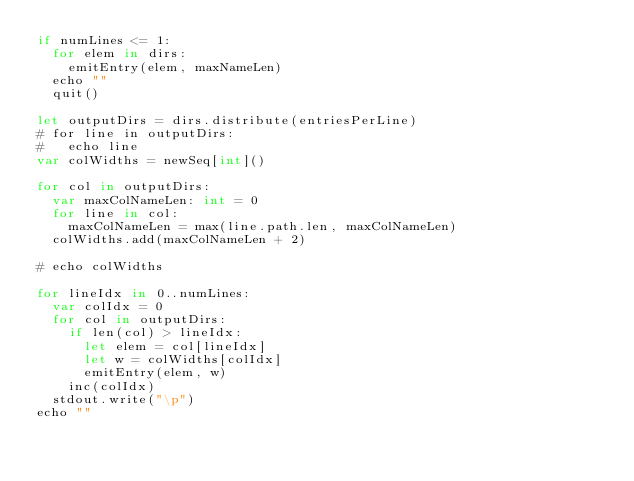<code> <loc_0><loc_0><loc_500><loc_500><_Nim_>if numLines <= 1:
  for elem in dirs:
    emitEntry(elem, maxNameLen)
  echo ""
  quit()

let outputDirs = dirs.distribute(entriesPerLine)
# for line in outputDirs:
#   echo line
var colWidths = newSeq[int]()

for col in outputDirs:
  var maxColNameLen: int = 0
  for line in col:
    maxColNameLen = max(line.path.len, maxColNameLen)
  colWidths.add(maxColNameLen + 2)

# echo colWidths

for lineIdx in 0..numLines:
  var colIdx = 0
  for col in outputDirs:
    if len(col) > lineIdx:
      let elem = col[lineIdx]
      let w = colWidths[colIdx]
      emitEntry(elem, w)
    inc(colIdx)
  stdout.write("\p")
echo ""
</code> 